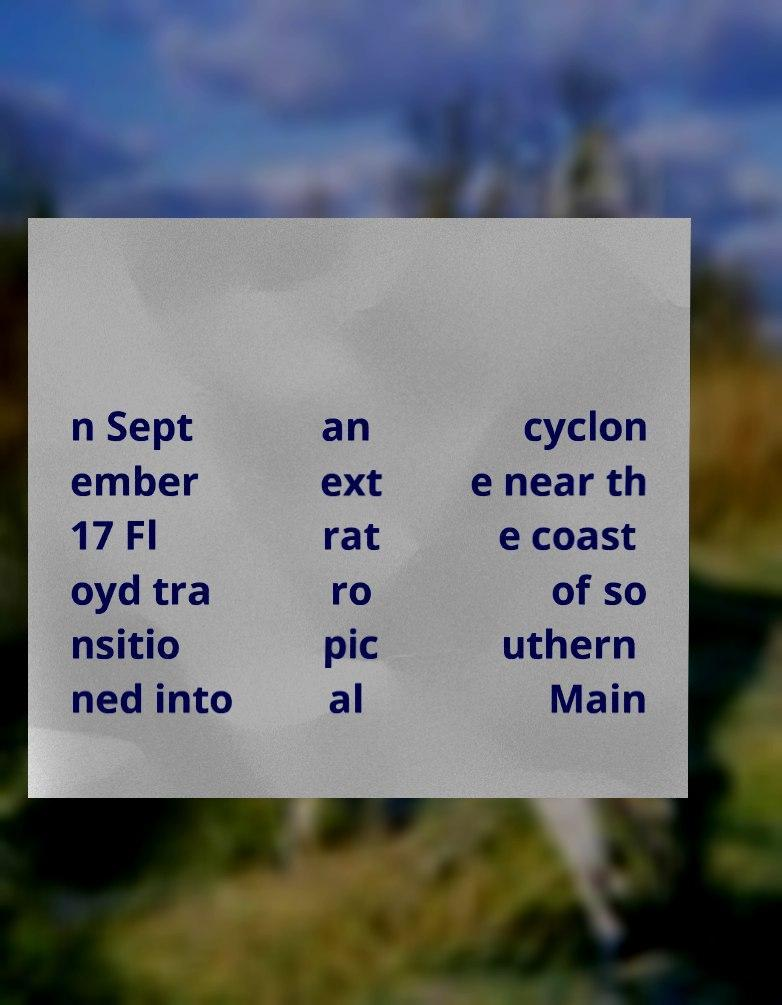I need the written content from this picture converted into text. Can you do that? n Sept ember 17 Fl oyd tra nsitio ned into an ext rat ro pic al cyclon e near th e coast of so uthern Main 